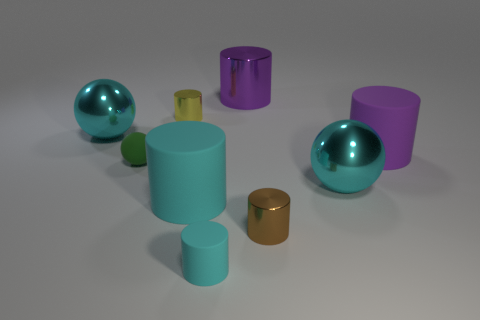Subtract 1 cylinders. How many cylinders are left? 5 Subtract all yellow cylinders. How many cylinders are left? 5 Subtract all brown cylinders. How many cylinders are left? 5 Subtract all brown cylinders. Subtract all red balls. How many cylinders are left? 5 Subtract all spheres. How many objects are left? 6 Subtract 2 purple cylinders. How many objects are left? 7 Subtract all purple metal things. Subtract all purple things. How many objects are left? 6 Add 7 green balls. How many green balls are left? 8 Add 4 green things. How many green things exist? 5 